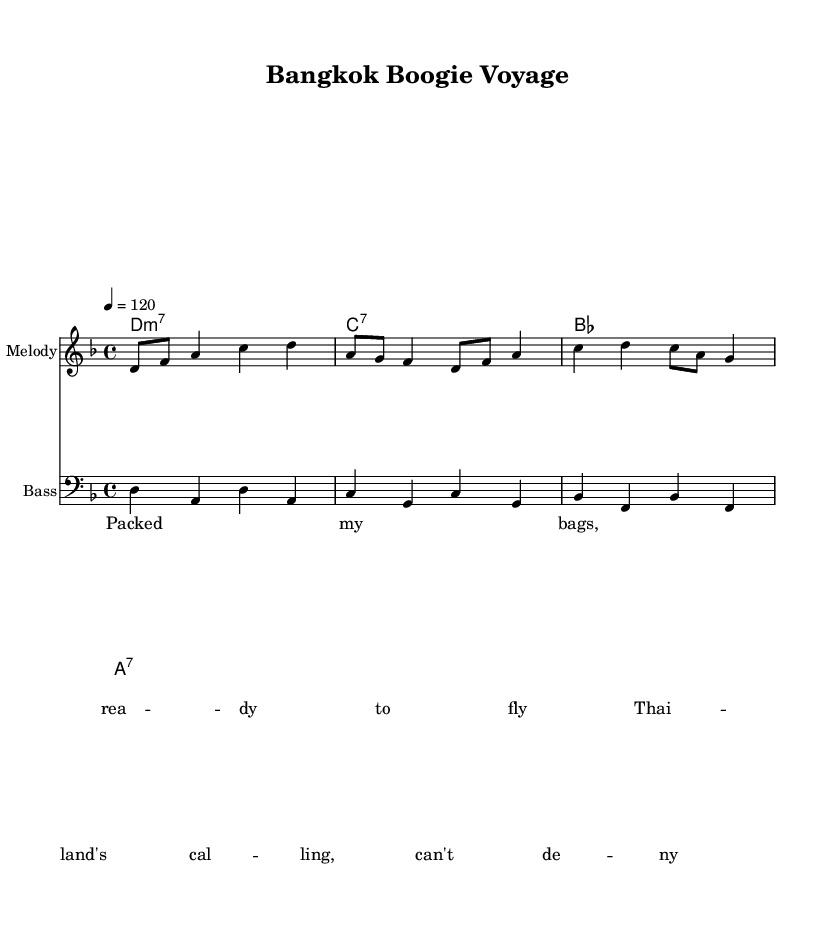What is the key signature of this music? The key signature is D minor, which has one flat (B flat). This can be determined by observing the key indicated at the beginning of the score.
Answer: D minor What is the time signature of this music? The time signature is 4/4, which means there are four beats per measure and the quarter note gets one beat. This is seen at the beginning of the score next to the key signature.
Answer: 4/4 What is the tempo marking for this piece? The tempo marking is a quarter note equals 120, indicating the speed of the music. It is specified at the beginning of the score, under the tempo indication.
Answer: 120 What are the first two notes of the melody? The first two notes of the melody are D and F. This can be identified by looking at the melody staff, where these notes are positioned at the very start.
Answer: D, F How many measures are in the bass line? There are four measures in the bass line, as indicated by the notation that separates each rhythmic grouping in the bass staff.
Answer: 4 Which chord is played in the last measure? The last measure features the chord A7, as stated in the chord names section. This can be confirmed by checking the chord indicated in the corresponding position at the end of the score.
Answer: A7 Identify the lyrical theme conveyed in the verse. The lyrical theme is about anticipation for travel, specifically to Thailand, as seen in the lyrics provided. They express readiness and excitement for the journey.
Answer: Travel anticipation 